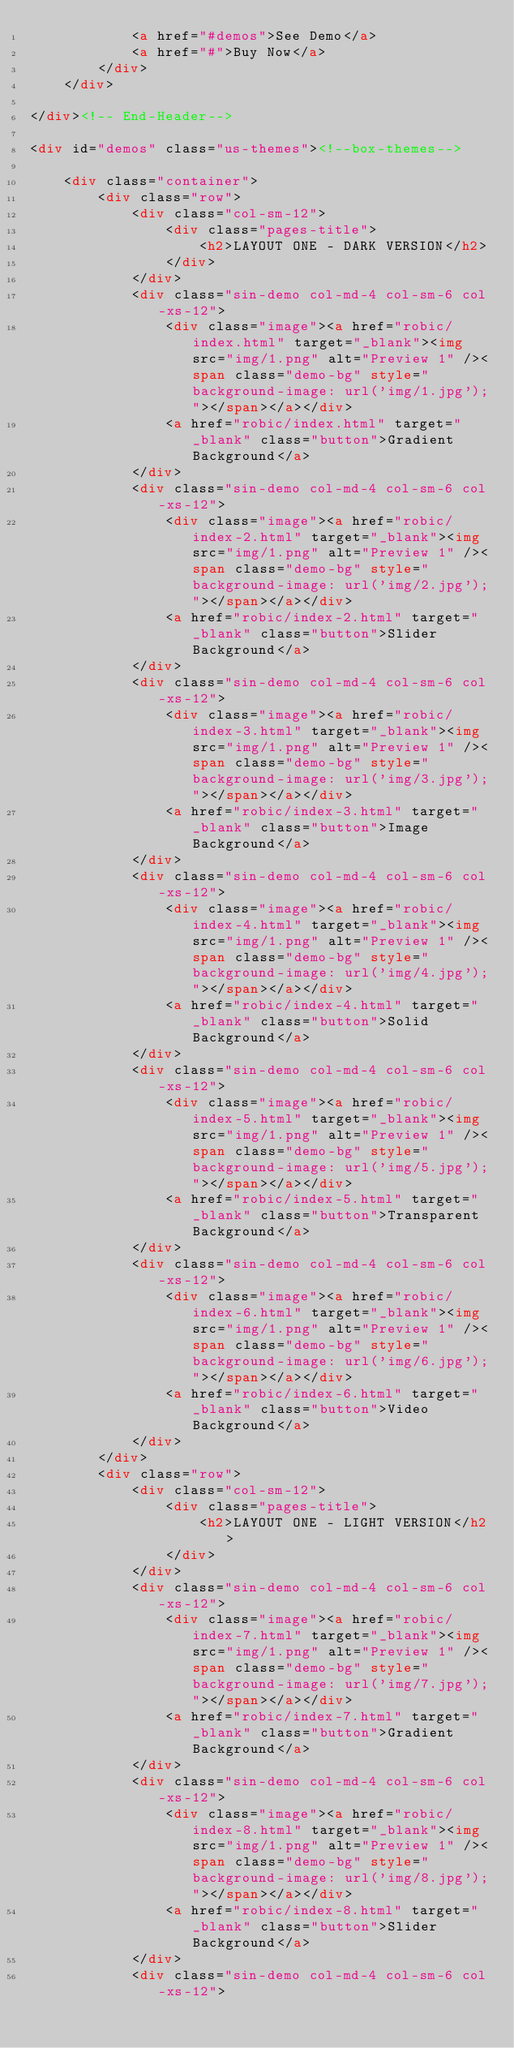<code> <loc_0><loc_0><loc_500><loc_500><_HTML_>			<a href="#demos">See Demo</a>
			<a href="#">Buy Now</a>
		</div>
	</div> 

</div><!-- End-Header-->

<div id="demos" class="us-themes"><!--box-themes-->
	
	<div class="container">
		<div class="row">
			<div class="col-sm-12">
				<div class="pages-title">
					<h2>LAYOUT ONE - DARK VERSION</h2>
				</div>
			</div>
			<div class="sin-demo col-md-4 col-sm-6 col-xs-12">
				<div class="image"><a href="robic/index.html" target="_blank"><img src="img/1.png" alt="Preview 1" /><span class="demo-bg" style="background-image: url('img/1.jpg');"></span></a></div> 
				<a href="robic/index.html" target="_blank" class="button">Gradient Background</a>
			</div>
			<div class="sin-demo col-md-4 col-sm-6 col-xs-12">
				<div class="image"><a href="robic/index-2.html" target="_blank"><img src="img/1.png" alt="Preview 1" /><span class="demo-bg" style="background-image: url('img/2.jpg');"></span></a></div> 
				<a href="robic/index-2.html" target="_blank" class="button">Slider Background</a>
			</div>
			<div class="sin-demo col-md-4 col-sm-6 col-xs-12">
				<div class="image"><a href="robic/index-3.html" target="_blank"><img src="img/1.png" alt="Preview 1" /><span class="demo-bg" style="background-image: url('img/3.jpg');"></span></a></div> 
				<a href="robic/index-3.html" target="_blank" class="button">Image Background</a>
			</div>
			<div class="sin-demo col-md-4 col-sm-6 col-xs-12">
				<div class="image"><a href="robic/index-4.html" target="_blank"><img src="img/1.png" alt="Preview 1" /><span class="demo-bg" style="background-image: url('img/4.jpg');"></span></a></div> 
				<a href="robic/index-4.html" target="_blank" class="button">Solid Background</a>
			</div>
			<div class="sin-demo col-md-4 col-sm-6 col-xs-12">
				<div class="image"><a href="robic/index-5.html" target="_blank"><img src="img/1.png" alt="Preview 1" /><span class="demo-bg" style="background-image: url('img/5.jpg');"></span></a></div> 
				<a href="robic/index-5.html" target="_blank" class="button">Transparent Background</a>
			</div>
			<div class="sin-demo col-md-4 col-sm-6 col-xs-12">
				<div class="image"><a href="robic/index-6.html" target="_blank"><img src="img/1.png" alt="Preview 1" /><span class="demo-bg" style="background-image: url('img/6.jpg');"></span></a></div> 
				<a href="robic/index-6.html" target="_blank" class="button">Video Background</a>
			</div>
		</div>
		<div class="row">
			<div class="col-sm-12">
				<div class="pages-title">
					<h2>LAYOUT ONE - LIGHT VERSION</h2>
				</div>
			</div>
			<div class="sin-demo col-md-4 col-sm-6 col-xs-12">
				<div class="image"><a href="robic/index-7.html" target="_blank"><img src="img/1.png" alt="Preview 1" /><span class="demo-bg" style="background-image: url('img/7.jpg');"></span></a></div> 
				<a href="robic/index-7.html" target="_blank" class="button">Gradient Background</a>
			</div>
			<div class="sin-demo col-md-4 col-sm-6 col-xs-12">
				<div class="image"><a href="robic/index-8.html" target="_blank"><img src="img/1.png" alt="Preview 1" /><span class="demo-bg" style="background-image: url('img/8.jpg');"></span></a></div> 
				<a href="robic/index-8.html" target="_blank" class="button">Slider Background</a>
			</div>
			<div class="sin-demo col-md-4 col-sm-6 col-xs-12"></code> 